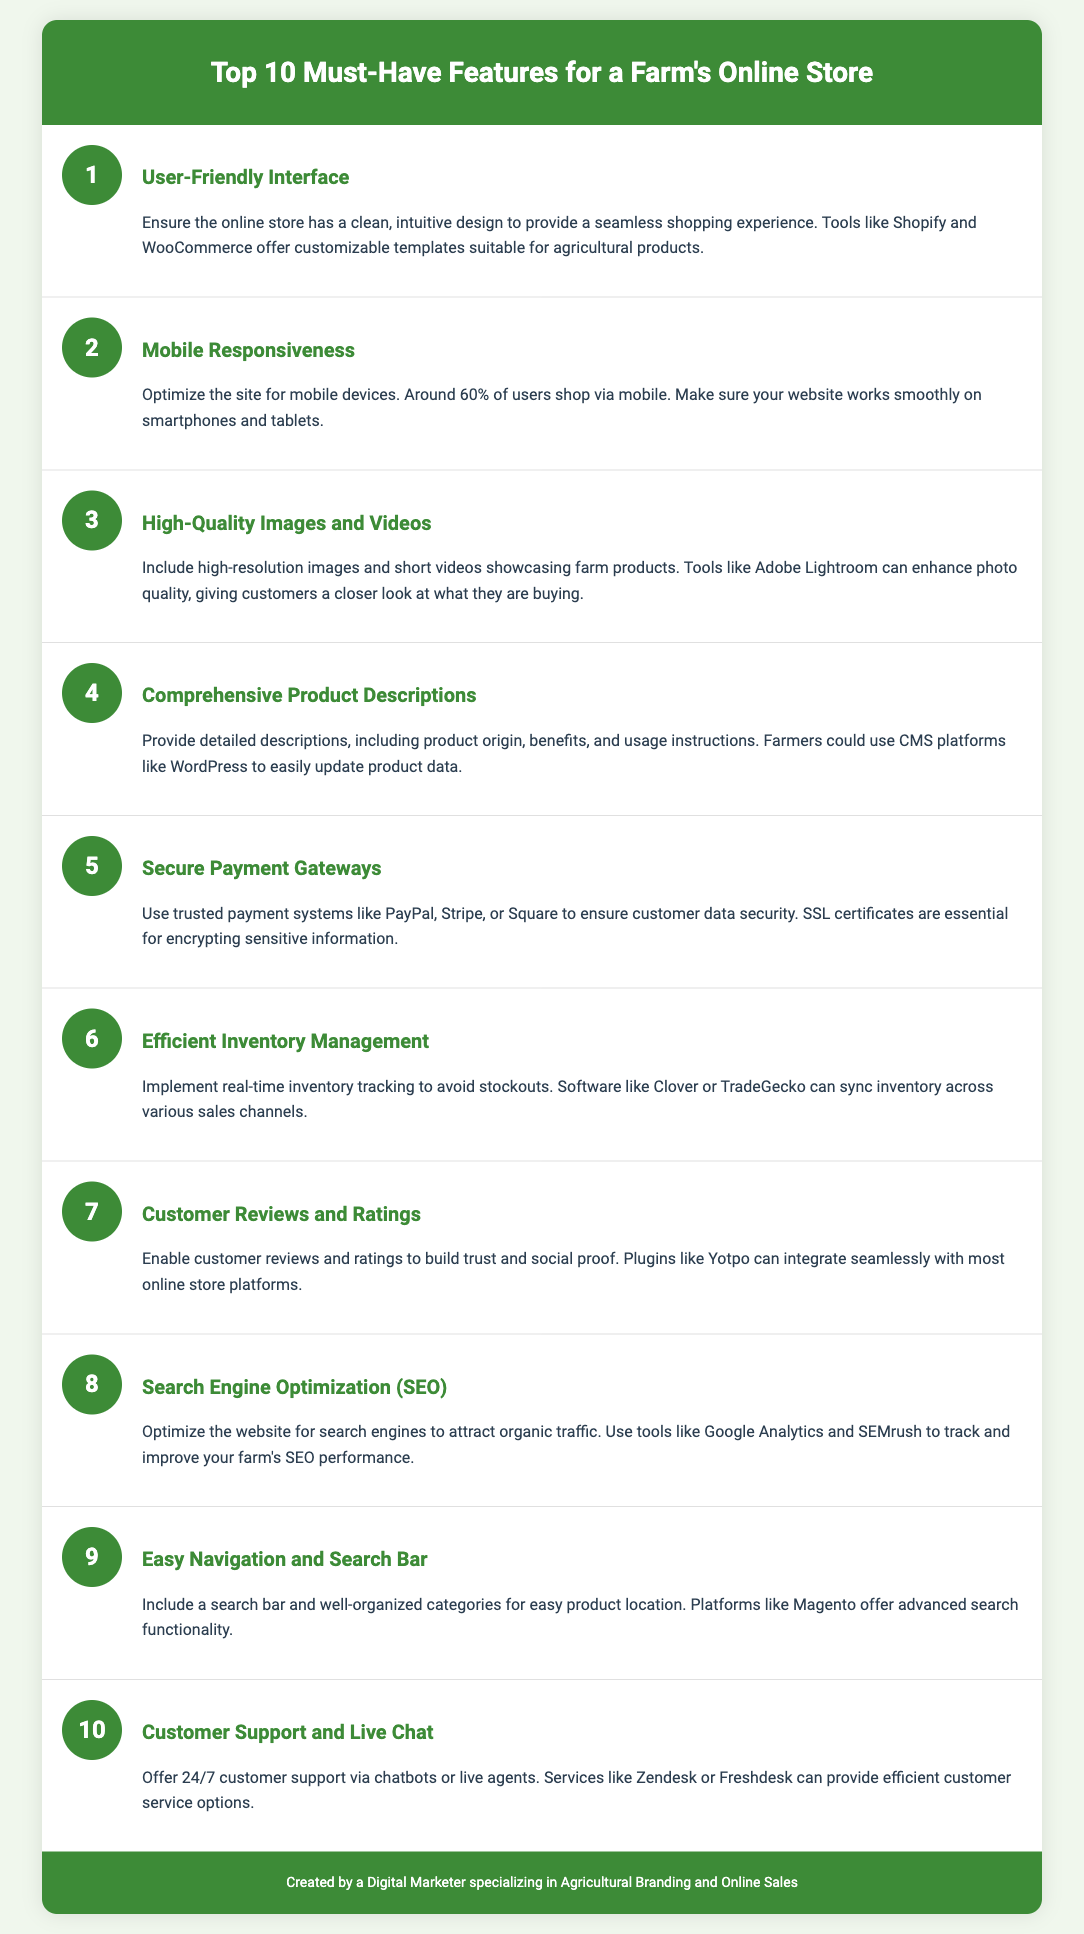What is the first feature listed for a farm's online store? The first feature listed is "User-Friendly Interface".
Answer: User-Friendly Interface How many features are included in the list? The document states there are ten features included in the list.
Answer: 10 Which feature emphasizes the importance of mobile optimization? The feature highlighting mobile optimization is "Mobile Responsiveness".
Answer: Mobile Responsiveness What should farmers use to showcase high-quality images? Farmers are recommended to use tools like "Adobe Lightroom" for enhancing photo quality.
Answer: Adobe Lightroom What is identified as a critical aspect of customer security in online stores? "Secure Payment Gateways" highlight the need for customer data security.
Answer: Secure Payment Gateways Which feature is essential for attracting organic traffic? "Search Engine Optimization (SEO)" is essential for attracting organic traffic.
Answer: Search Engine Optimization (SEO) What feature aims to improve customer trust and proof? The feature that improves customer trust is "Customer Reviews and Ratings".
Answer: Customer Reviews and Ratings What type of customer support is recommended for online stores? The document suggests offering "24/7 customer support" for online stores.
Answer: 24/7 customer support 